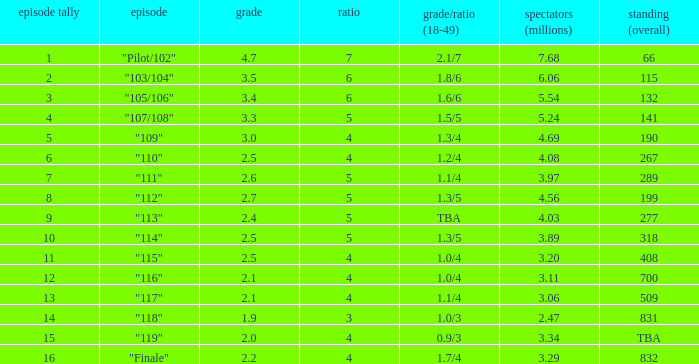WHAT IS THE NUMBER OF VIEWERS WITH EPISODE LARGER THAN 10, RATING SMALLER THAN 2? 2.47. 